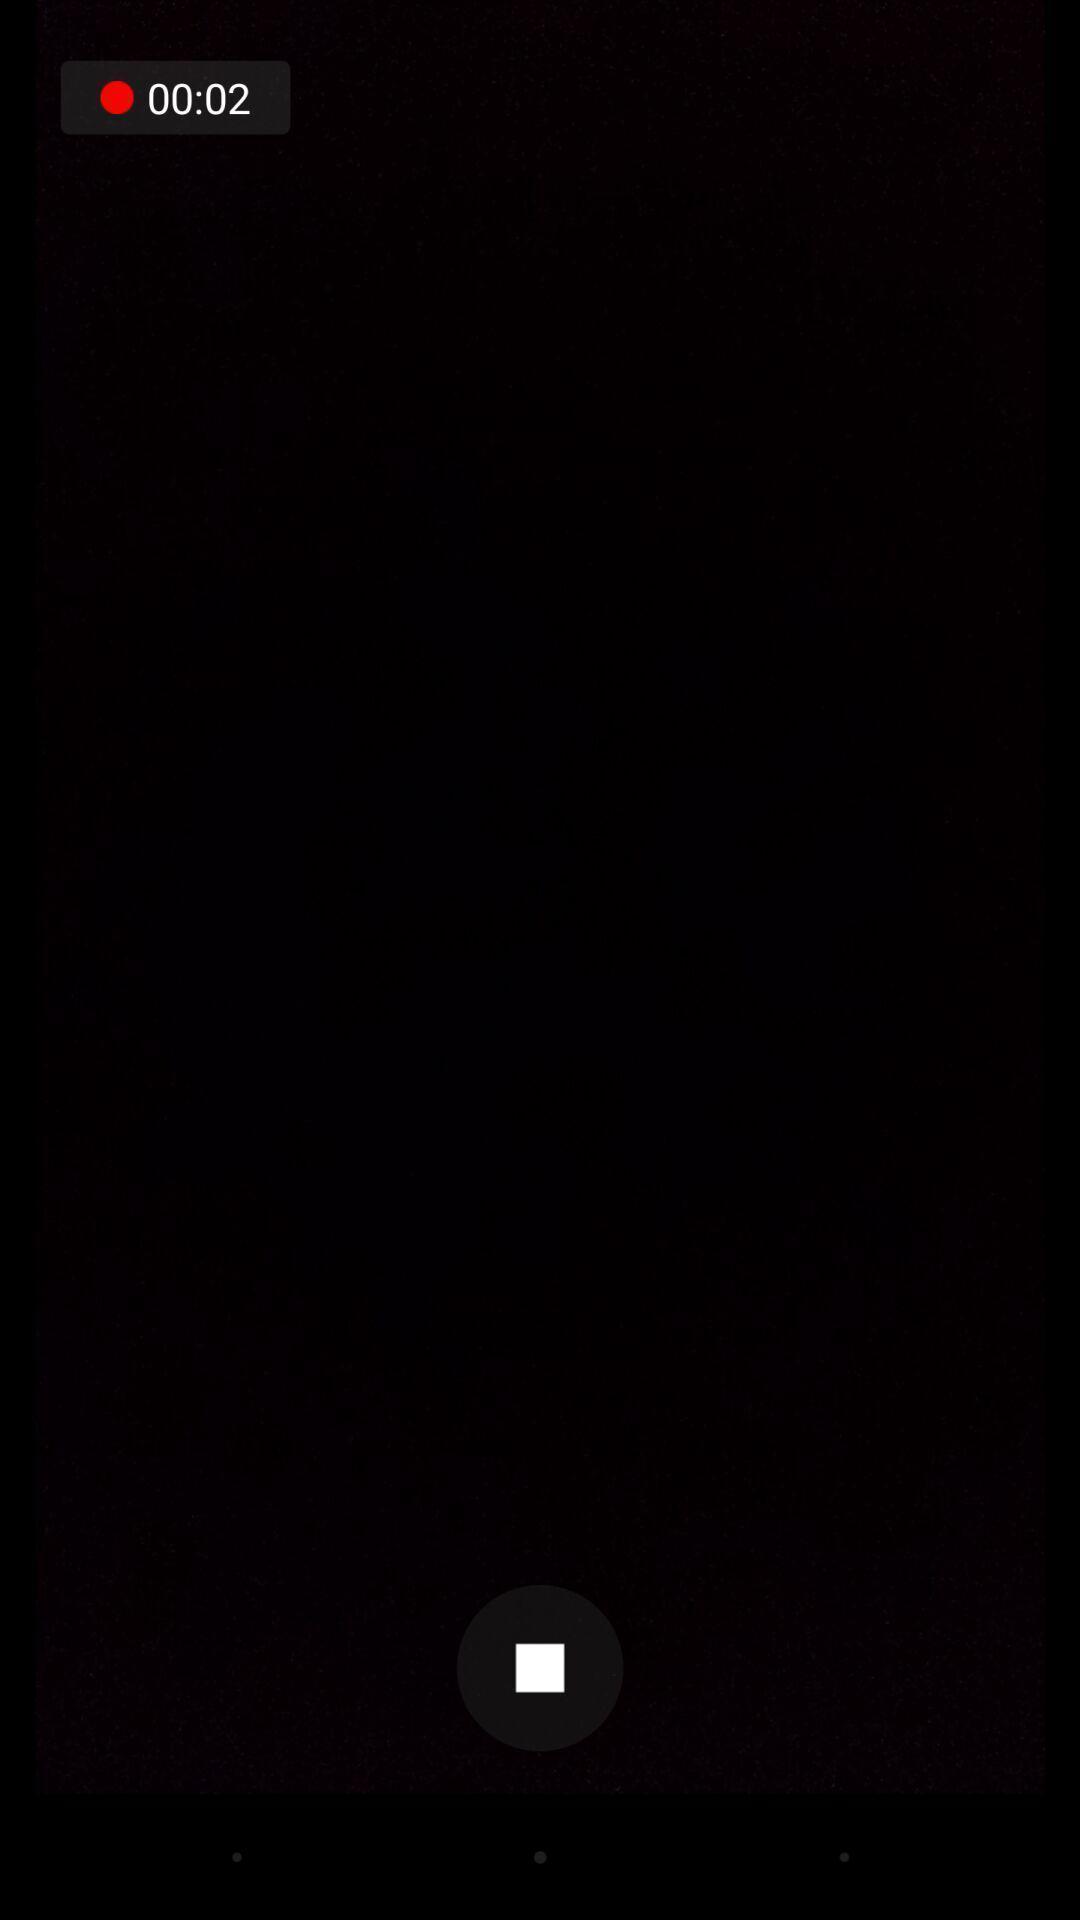Describe the visual elements of this screenshot. Page displaying with video recording. 